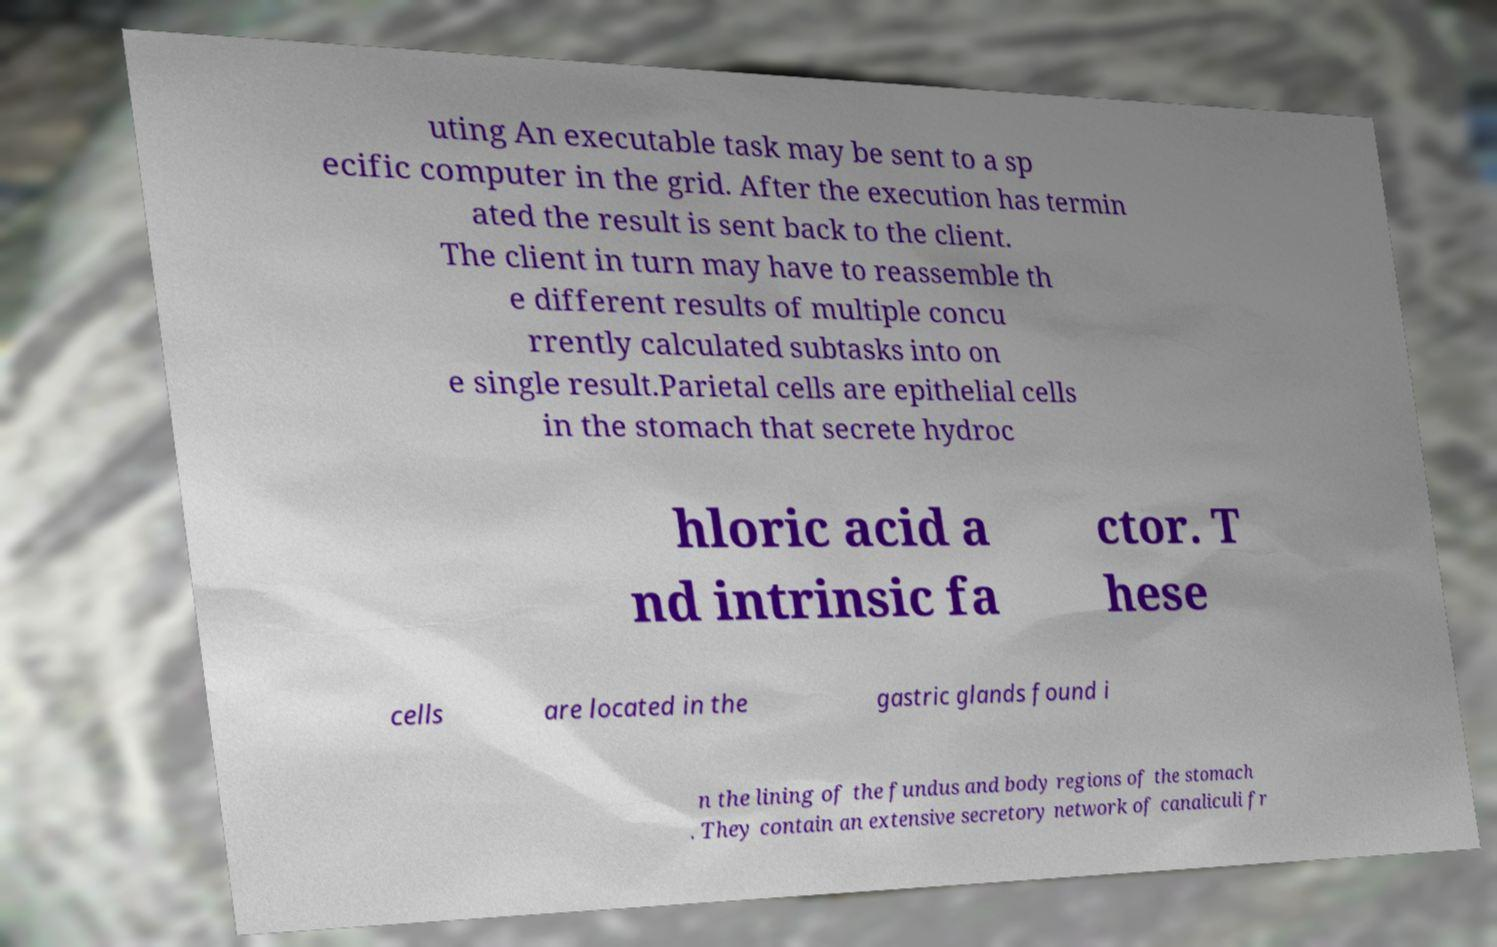Could you extract and type out the text from this image? uting An executable task may be sent to a sp ecific computer in the grid. After the execution has termin ated the result is sent back to the client. The client in turn may have to reassemble th e different results of multiple concu rrently calculated subtasks into on e single result.Parietal cells are epithelial cells in the stomach that secrete hydroc hloric acid a nd intrinsic fa ctor. T hese cells are located in the gastric glands found i n the lining of the fundus and body regions of the stomach . They contain an extensive secretory network of canaliculi fr 